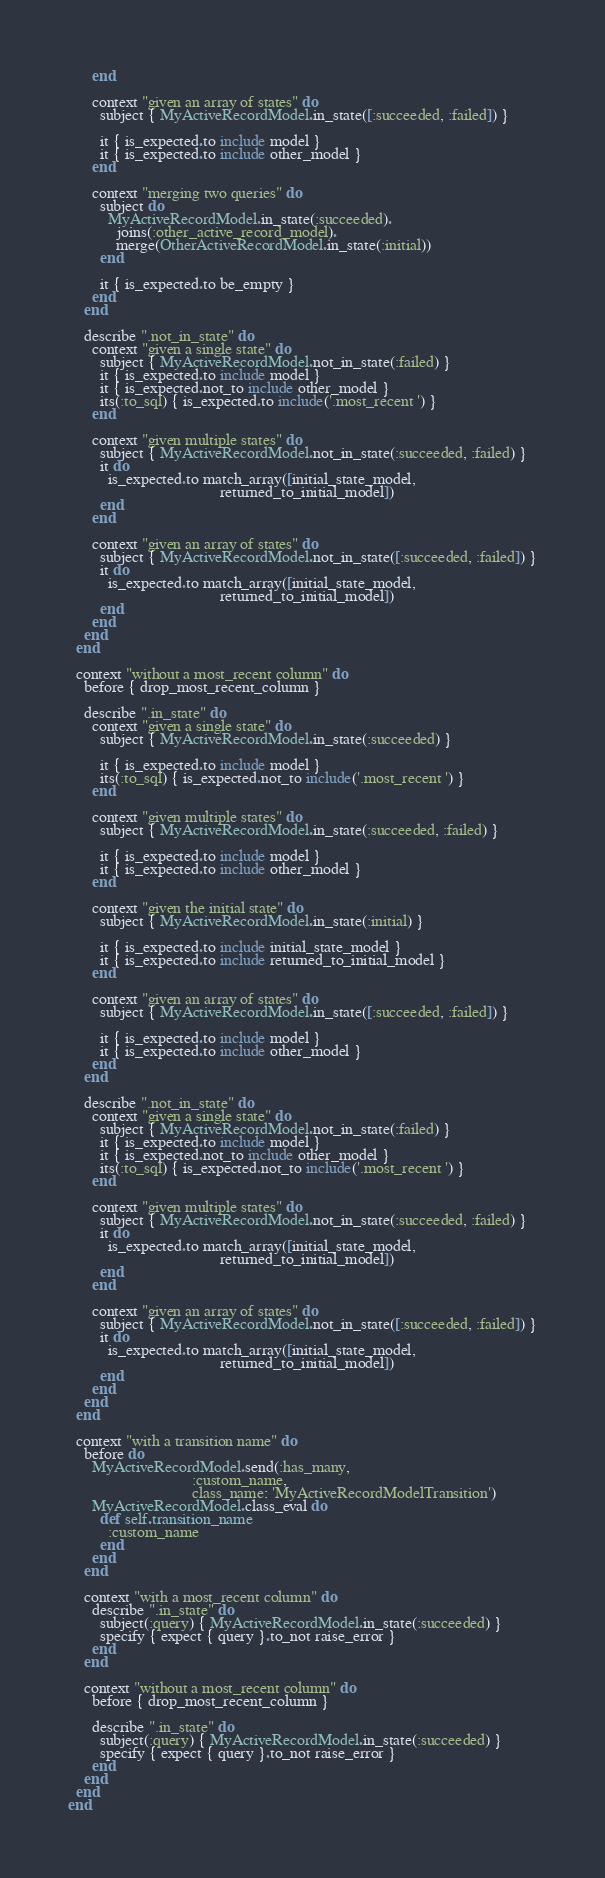Convert code to text. <code><loc_0><loc_0><loc_500><loc_500><_Ruby_>      end

      context "given an array of states" do
        subject { MyActiveRecordModel.in_state([:succeeded, :failed]) }

        it { is_expected.to include model }
        it { is_expected.to include other_model }
      end

      context "merging two queries" do
        subject do
          MyActiveRecordModel.in_state(:succeeded).
            joins(:other_active_record_model).
            merge(OtherActiveRecordModel.in_state(:initial))
        end

        it { is_expected.to be_empty }
      end
    end

    describe ".not_in_state" do
      context "given a single state" do
        subject { MyActiveRecordModel.not_in_state(:failed) }
        it { is_expected.to include model }
        it { is_expected.not_to include other_model }
        its(:to_sql) { is_expected.to include('.most_recent ') }
      end

      context "given multiple states" do
        subject { MyActiveRecordModel.not_in_state(:succeeded, :failed) }
        it do
          is_expected.to match_array([initial_state_model,
                                      returned_to_initial_model])
        end
      end

      context "given an array of states" do
        subject { MyActiveRecordModel.not_in_state([:succeeded, :failed]) }
        it do
          is_expected.to match_array([initial_state_model,
                                      returned_to_initial_model])
        end
      end
    end
  end

  context "without a most_recent column" do
    before { drop_most_recent_column }

    describe ".in_state" do
      context "given a single state" do
        subject { MyActiveRecordModel.in_state(:succeeded) }

        it { is_expected.to include model }
        its(:to_sql) { is_expected.not_to include('.most_recent ') }
      end

      context "given multiple states" do
        subject { MyActiveRecordModel.in_state(:succeeded, :failed) }

        it { is_expected.to include model }
        it { is_expected.to include other_model }
      end

      context "given the initial state" do
        subject { MyActiveRecordModel.in_state(:initial) }

        it { is_expected.to include initial_state_model }
        it { is_expected.to include returned_to_initial_model }
      end

      context "given an array of states" do
        subject { MyActiveRecordModel.in_state([:succeeded, :failed]) }

        it { is_expected.to include model }
        it { is_expected.to include other_model }
      end
    end

    describe ".not_in_state" do
      context "given a single state" do
        subject { MyActiveRecordModel.not_in_state(:failed) }
        it { is_expected.to include model }
        it { is_expected.not_to include other_model }
        its(:to_sql) { is_expected.not_to include('.most_recent ') }
      end

      context "given multiple states" do
        subject { MyActiveRecordModel.not_in_state(:succeeded, :failed) }
        it do
          is_expected.to match_array([initial_state_model,
                                      returned_to_initial_model])
        end
      end

      context "given an array of states" do
        subject { MyActiveRecordModel.not_in_state([:succeeded, :failed]) }
        it do
          is_expected.to match_array([initial_state_model,
                                      returned_to_initial_model])
        end
      end
    end
  end

  context "with a transition name" do
    before do
      MyActiveRecordModel.send(:has_many,
                               :custom_name,
                               class_name: 'MyActiveRecordModelTransition')
      MyActiveRecordModel.class_eval do
        def self.transition_name
          :custom_name
        end
      end
    end

    context "with a most_recent column" do
      describe ".in_state" do
        subject(:query) { MyActiveRecordModel.in_state(:succeeded) }
        specify { expect { query }.to_not raise_error }
      end
    end

    context "without a most_recent column" do
      before { drop_most_recent_column }

      describe ".in_state" do
        subject(:query) { MyActiveRecordModel.in_state(:succeeded) }
        specify { expect { query }.to_not raise_error }
      end
    end
  end
end
</code> 